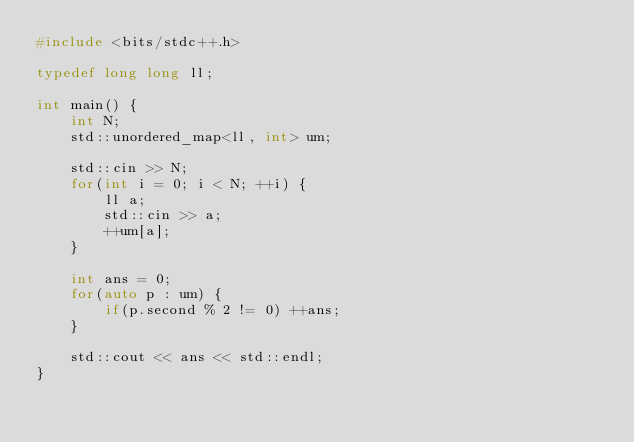<code> <loc_0><loc_0><loc_500><loc_500><_C++_>#include <bits/stdc++.h>

typedef long long ll;

int main() {
	int N;
	std::unordered_map<ll, int> um;

	std::cin >> N;
	for(int i = 0; i < N; ++i) {
		ll a;
		std::cin >> a;
		++um[a];
	}

	int ans = 0;
	for(auto p : um) {
		if(p.second % 2 != 0) ++ans;
	}

	std::cout << ans << std::endl;
}
</code> 